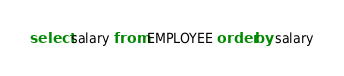<code> <loc_0><loc_0><loc_500><loc_500><_SQL_>select salary from EMPLOYEE order by salary</code> 